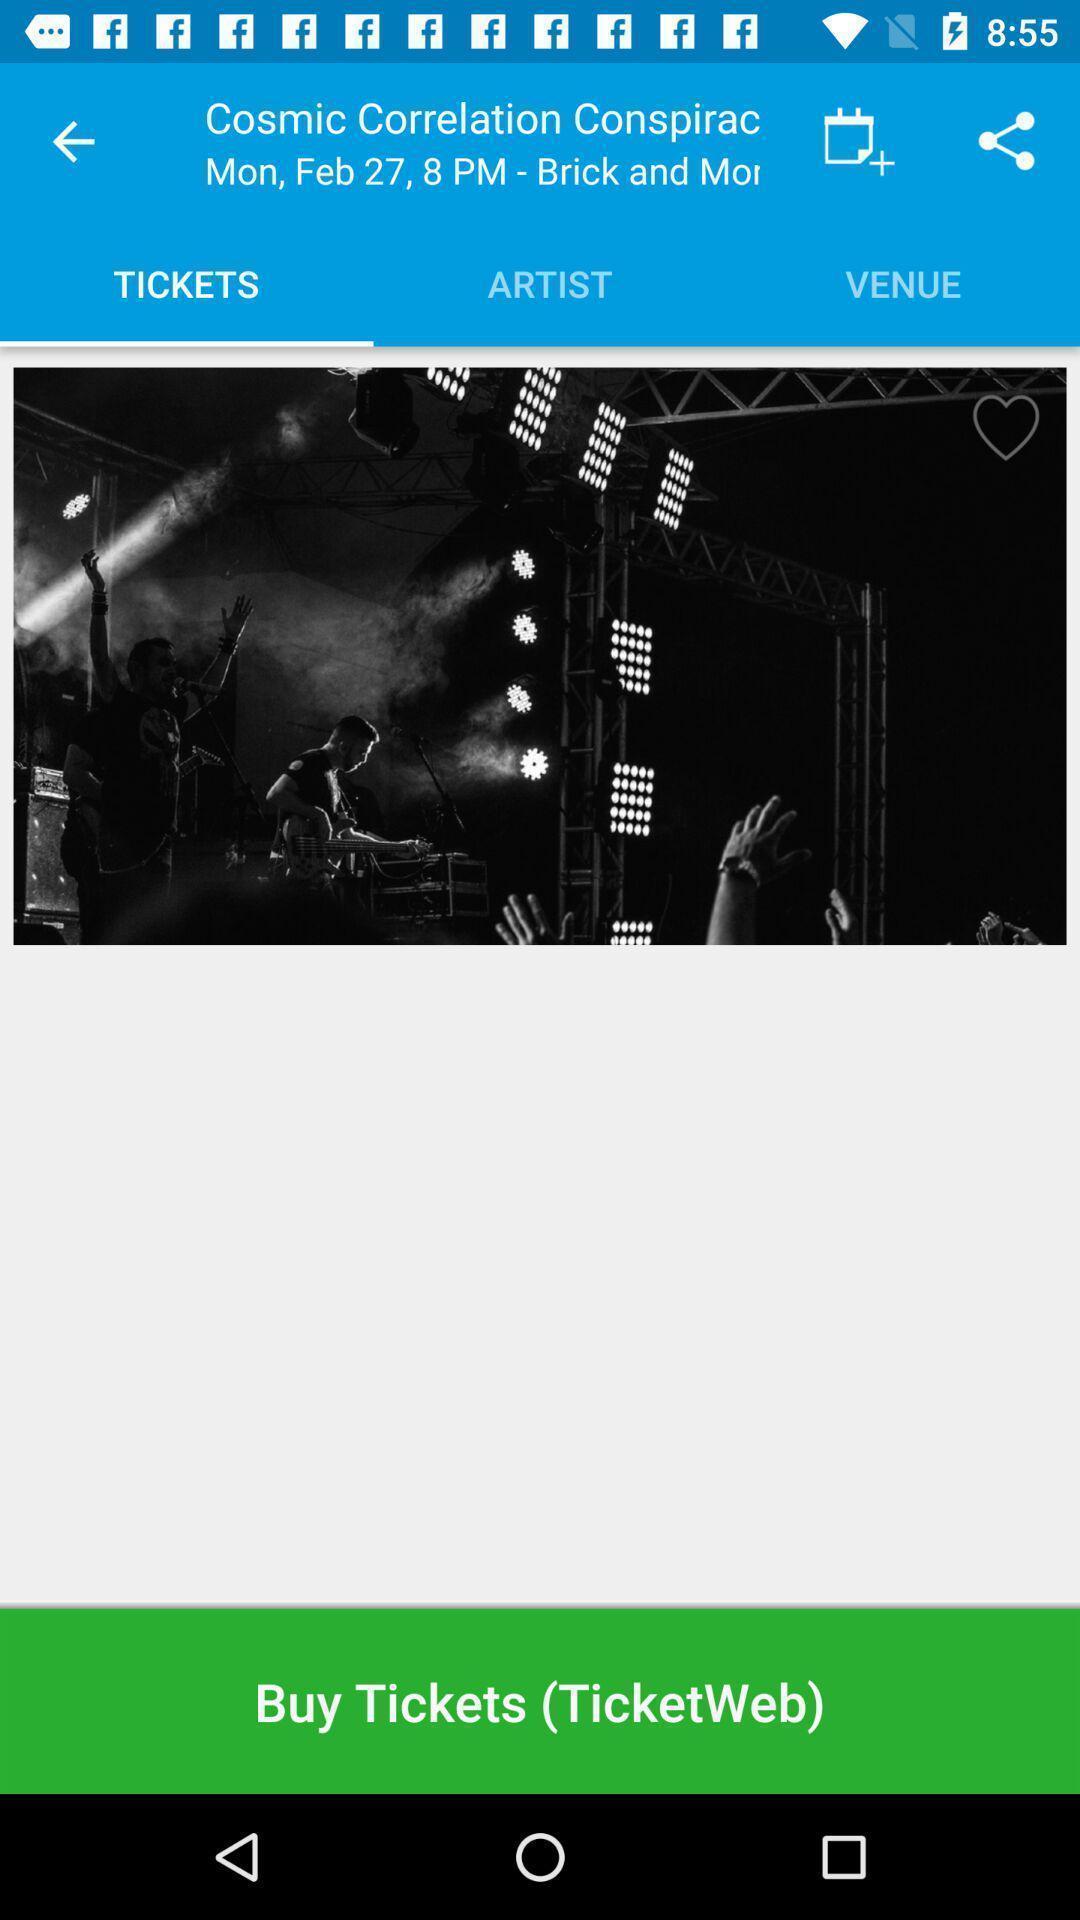Describe this image in words. Screen displaying the ticket booking page. 